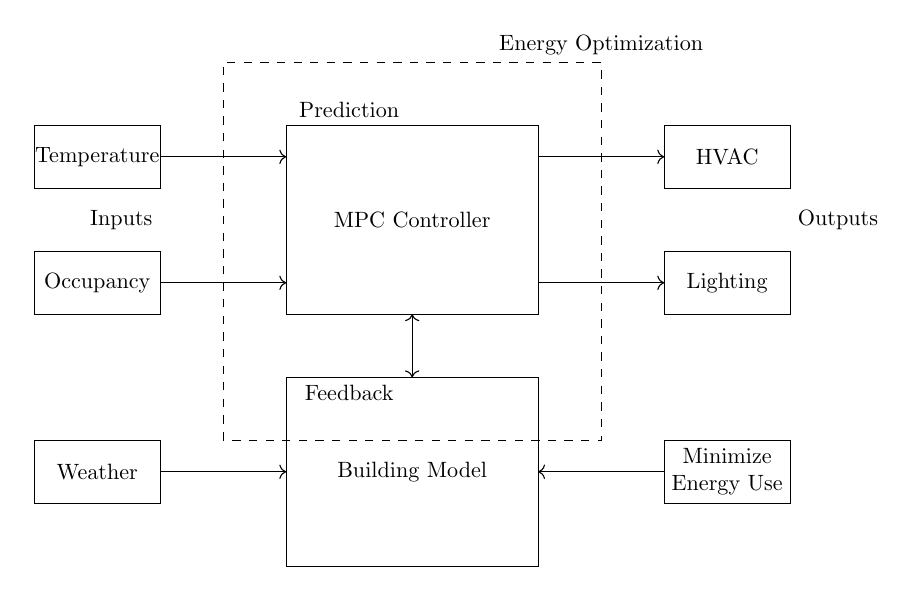What is the main component in the circuit? The main component is the MPC Controller, which is shown as a rectangle labeled "MPC Controller." It coordinates the inputs and outputs for energy optimization.
Answer: MPC Controller What is one of the inputs to the MPC Controller? The inputs to the MPC Controller include Temperature and Occupancy, which are depicted as separate rectangles connected to the controller.
Answer: Temperature What type of optimization objective is indicated in the circuit? The optimization objective is to "Minimize Energy Use," indicated by a rectangle on the right side of the circuit diagram. This suggests that the control strategy focuses on reducing energy consumption.
Answer: Minimize Energy Use How many sensors are shown in the diagram? There are two sensors indicated in the diagram: one for Temperature and one for Occupancy, each represented by rectangles connected to the MPC Controller.
Answer: Two What is the role of the HVAC in this circuit? The HVAC is an actuator shown in the right section of the circuit diagram, which receives commands from the MPC Controller to optimize heating, ventilation, and air conditioning performance.
Answer: Actuator Explain the relationship between the "Building Model" and the "Energy Optimization" area. The Building Model and the Energy Optimization areas are connected as indicated by the double-headed arrow between the two rectangles. This signifies that the MPC Controller uses the building model to inform its optimization processes.
Answer: Inform energy optimization What external factor is considered in the algorithm? The external factor recognized in the algorithm is the Weather, which is represented as a rectangle at the bottom left of the circuit diagram connected to the MPC Controller.
Answer: Weather 